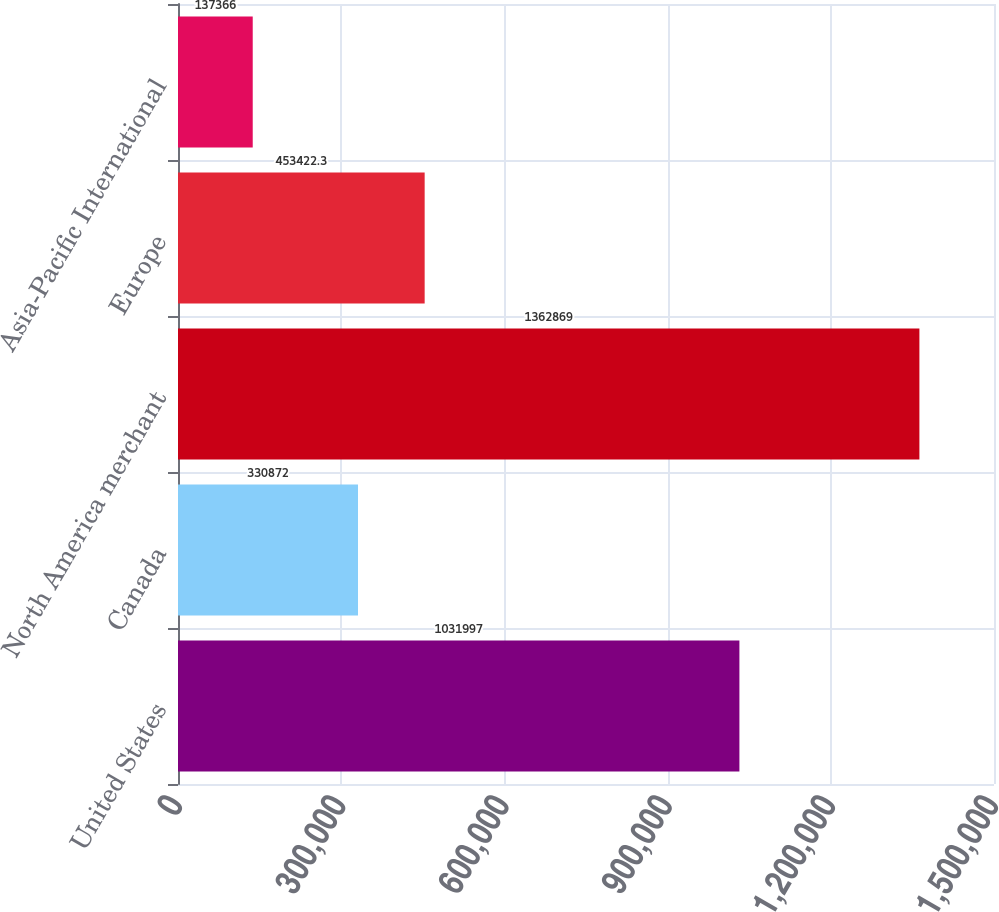Convert chart. <chart><loc_0><loc_0><loc_500><loc_500><bar_chart><fcel>United States<fcel>Canada<fcel>North America merchant<fcel>Europe<fcel>Asia-Pacific International<nl><fcel>1.032e+06<fcel>330872<fcel>1.36287e+06<fcel>453422<fcel>137366<nl></chart> 